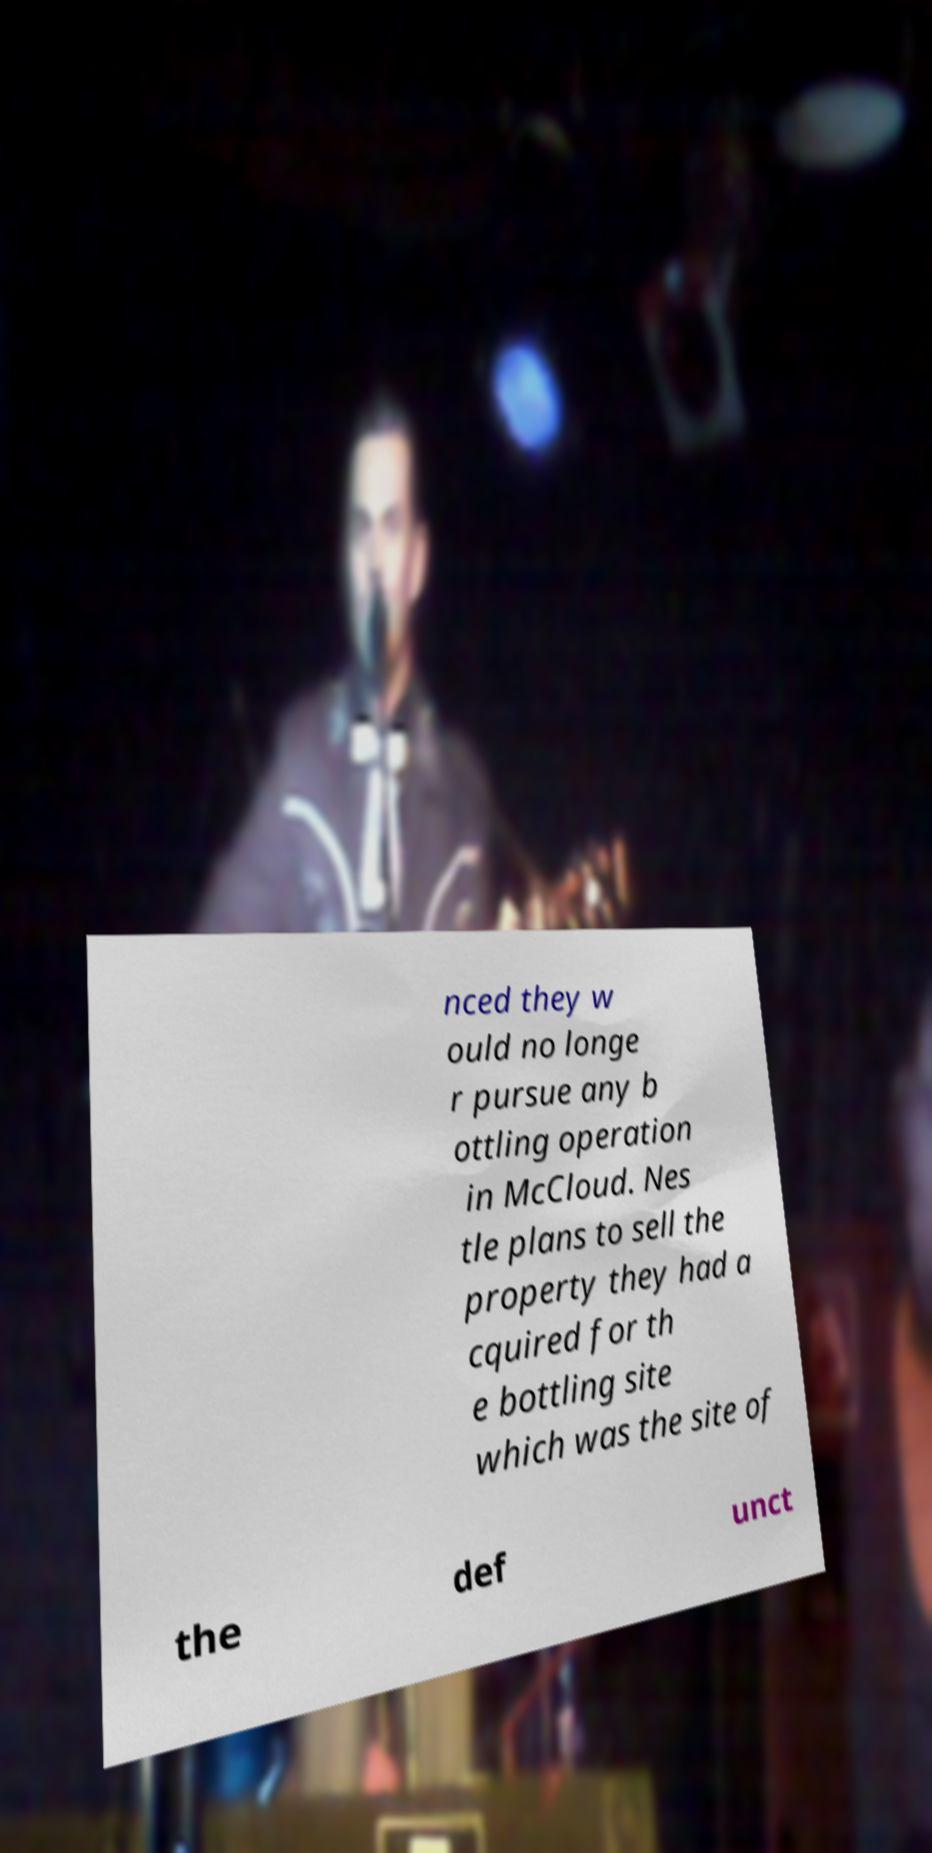I need the written content from this picture converted into text. Can you do that? nced they w ould no longe r pursue any b ottling operation in McCloud. Nes tle plans to sell the property they had a cquired for th e bottling site which was the site of the def unct 